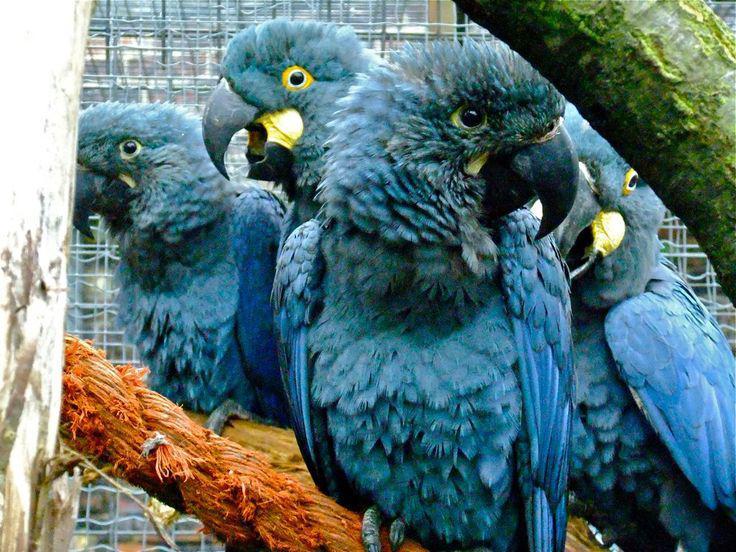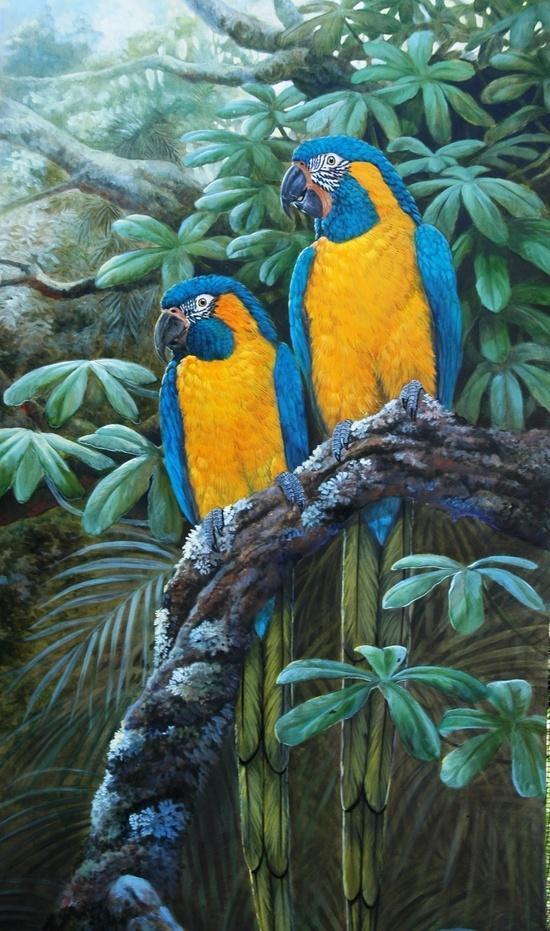The first image is the image on the left, the second image is the image on the right. For the images shown, is this caption "Two birds sit on a branch in the image on the right." true? Answer yes or no. Yes. The first image is the image on the left, the second image is the image on the right. Assess this claim about the two images: "An image includes blue parrots with bright yellow chests.". Correct or not? Answer yes or no. Yes. 